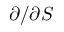Convert formula to latex. <formula><loc_0><loc_0><loc_500><loc_500>\partial / \partial S</formula> 